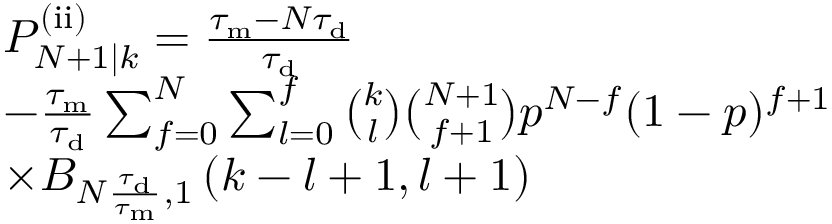<formula> <loc_0><loc_0><loc_500><loc_500>\begin{array} { r l } & { P _ { N + 1 | k } ^ { ( i i ) } = \frac { \tau _ { m } - N \tau _ { d } } { \tau _ { d } } } \\ & { - \frac { \tau _ { m } } { \tau _ { d } } \sum _ { f = 0 } ^ { N } \sum _ { l = 0 } ^ { f } \binom { k } { l } \binom { N + 1 } { f + 1 } p ^ { N - f } ( 1 - p ) ^ { f + 1 } } \\ & { \times B _ { N \frac { \tau _ { d } } { \tau _ { m } } , 1 } \left ( k - l + 1 , l + 1 \right ) } \end{array}</formula> 